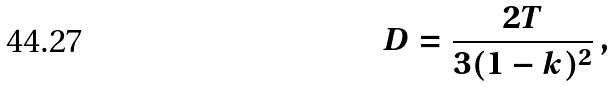Convert formula to latex. <formula><loc_0><loc_0><loc_500><loc_500>D = \frac { 2 T } { 3 ( 1 - k ) ^ { 2 } } \, ,</formula> 